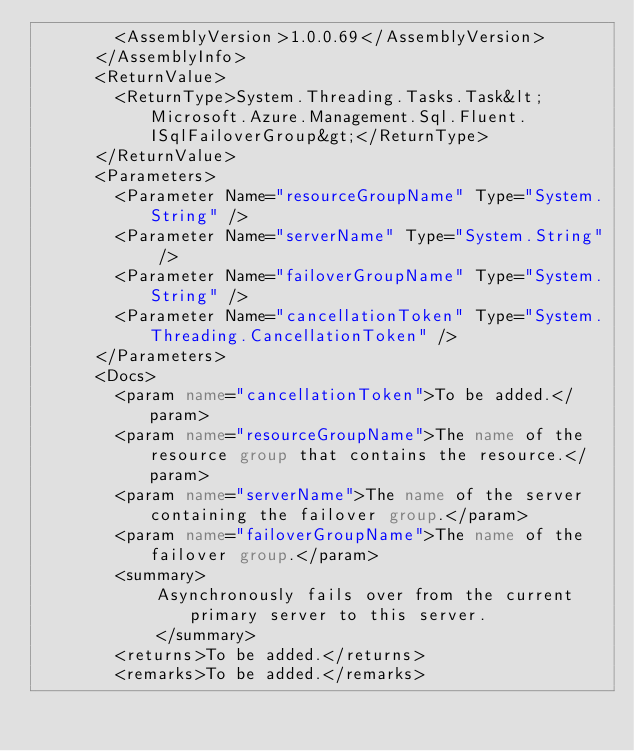Convert code to text. <code><loc_0><loc_0><loc_500><loc_500><_XML_>        <AssemblyVersion>1.0.0.69</AssemblyVersion>
      </AssemblyInfo>
      <ReturnValue>
        <ReturnType>System.Threading.Tasks.Task&lt;Microsoft.Azure.Management.Sql.Fluent.ISqlFailoverGroup&gt;</ReturnType>
      </ReturnValue>
      <Parameters>
        <Parameter Name="resourceGroupName" Type="System.String" />
        <Parameter Name="serverName" Type="System.String" />
        <Parameter Name="failoverGroupName" Type="System.String" />
        <Parameter Name="cancellationToken" Type="System.Threading.CancellationToken" />
      </Parameters>
      <Docs>
        <param name="cancellationToken">To be added.</param>
        <param name="resourceGroupName">The name of the resource group that contains the resource.</param>
        <param name="serverName">The name of the server containing the failover group.</param>
        <param name="failoverGroupName">The name of the failover group.</param>
        <summary>
            Asynchronously fails over from the current primary server to this server.
            </summary>
        <returns>To be added.</returns>
        <remarks>To be added.</remarks></code> 